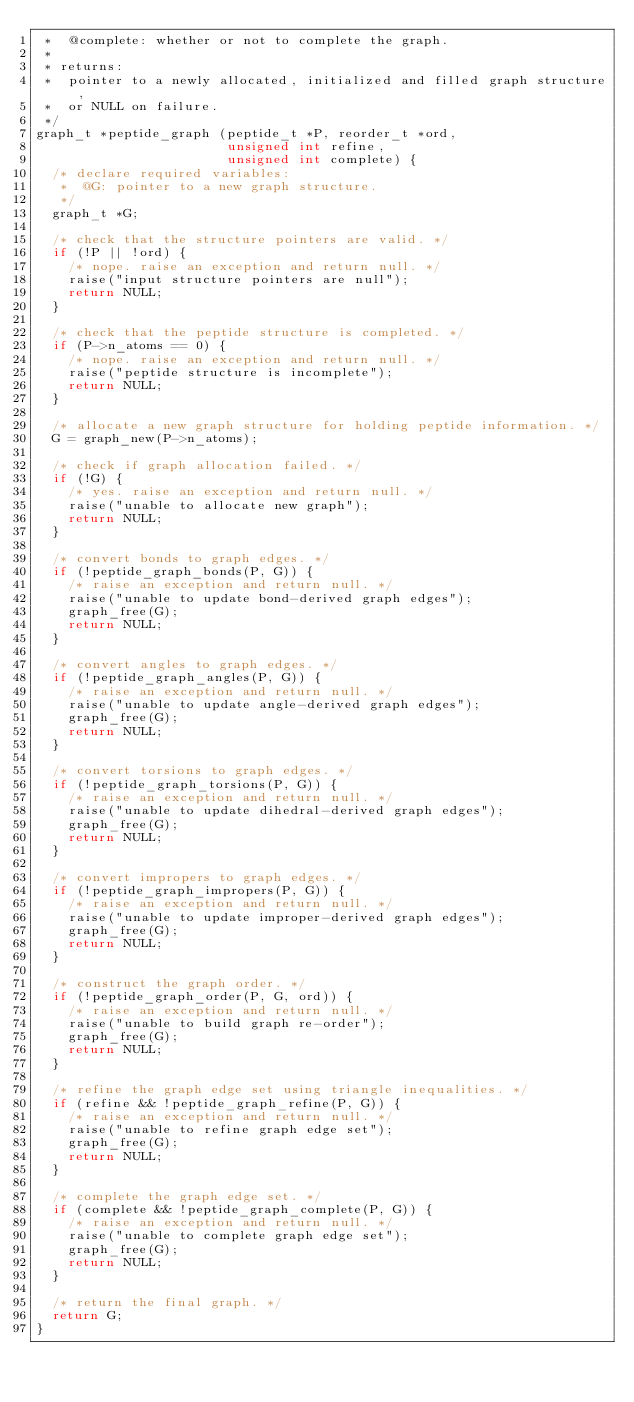<code> <loc_0><loc_0><loc_500><loc_500><_C_> *  @complete: whether or not to complete the graph.
 *
 * returns:
 *  pointer to a newly allocated, initialized and filled graph structure,
 *  or NULL on failure.
 */
graph_t *peptide_graph (peptide_t *P, reorder_t *ord,
                        unsigned int refine,
                        unsigned int complete) {
  /* declare required variables:
   *  @G: pointer to a new graph structure.
   */
  graph_t *G;

  /* check that the structure pointers are valid. */
  if (!P || !ord) {
    /* nope. raise an exception and return null. */
    raise("input structure pointers are null");
    return NULL;
  }

  /* check that the peptide structure is completed. */
  if (P->n_atoms == 0) {
    /* nope. raise an exception and return null. */
    raise("peptide structure is incomplete");
    return NULL;
  }

  /* allocate a new graph structure for holding peptide information. */
  G = graph_new(P->n_atoms);

  /* check if graph allocation failed. */
  if (!G) {
    /* yes. raise an exception and return null. */
    raise("unable to allocate new graph");
    return NULL;
  }

  /* convert bonds to graph edges. */
  if (!peptide_graph_bonds(P, G)) {
    /* raise an exception and return null. */
    raise("unable to update bond-derived graph edges");
    graph_free(G);
    return NULL;
  }

  /* convert angles to graph edges. */
  if (!peptide_graph_angles(P, G)) {
    /* raise an exception and return null. */
    raise("unable to update angle-derived graph edges");
    graph_free(G);
    return NULL;
  }

  /* convert torsions to graph edges. */
  if (!peptide_graph_torsions(P, G)) {
    /* raise an exception and return null. */
    raise("unable to update dihedral-derived graph edges");
    graph_free(G);
    return NULL;
  }

  /* convert impropers to graph edges. */
  if (!peptide_graph_impropers(P, G)) {
    /* raise an exception and return null. */
    raise("unable to update improper-derived graph edges");
    graph_free(G);
    return NULL;
  }

  /* construct the graph order. */
  if (!peptide_graph_order(P, G, ord)) {
    /* raise an exception and return null. */
    raise("unable to build graph re-order");
    graph_free(G);
    return NULL;
  }

  /* refine the graph edge set using triangle inequalities. */
  if (refine && !peptide_graph_refine(P, G)) {
    /* raise an exception and return null. */
    raise("unable to refine graph edge set");
    graph_free(G);
    return NULL;
  }

  /* complete the graph edge set. */
  if (complete && !peptide_graph_complete(P, G)) {
    /* raise an exception and return null. */
    raise("unable to complete graph edge set");
    graph_free(G);
    return NULL;
  }

  /* return the final graph. */
  return G;
}

</code> 